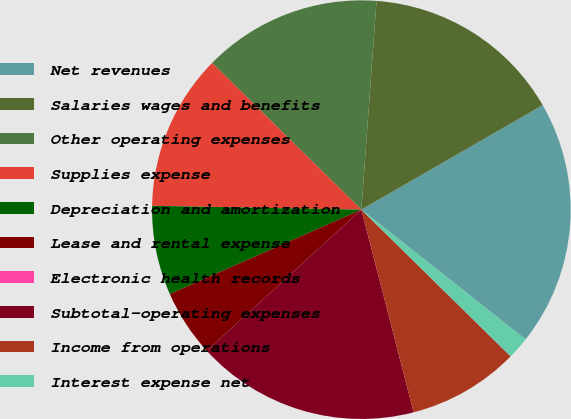Convert chart to OTSL. <chart><loc_0><loc_0><loc_500><loc_500><pie_chart><fcel>Net revenues<fcel>Salaries wages and benefits<fcel>Other operating expenses<fcel>Supplies expense<fcel>Depreciation and amortization<fcel>Lease and rental expense<fcel>Electronic health records<fcel>Subtotal-operating expenses<fcel>Income from operations<fcel>Interest expense net<nl><fcel>18.97%<fcel>15.52%<fcel>13.79%<fcel>12.07%<fcel>6.9%<fcel>5.17%<fcel>0.0%<fcel>17.24%<fcel>8.62%<fcel>1.72%<nl></chart> 